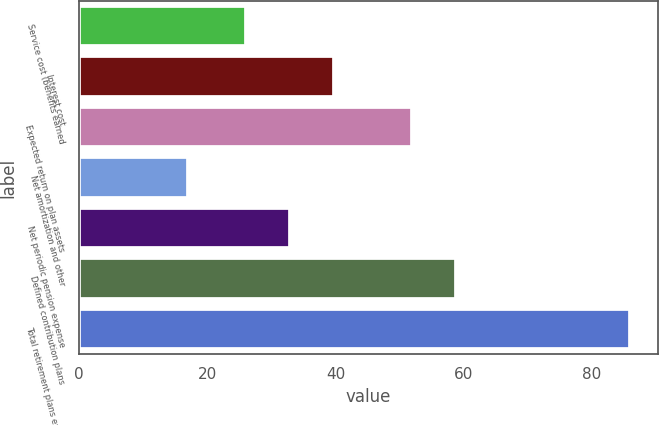Convert chart to OTSL. <chart><loc_0><loc_0><loc_500><loc_500><bar_chart><fcel>Service cost (benefits earned<fcel>Interest cost<fcel>Expected return on plan assets<fcel>Net amortization and other<fcel>Net periodic pension expense<fcel>Defined contribution plans<fcel>Total retirement plans expense<nl><fcel>26<fcel>39.8<fcel>52<fcel>17<fcel>32.9<fcel>58.9<fcel>86<nl></chart> 